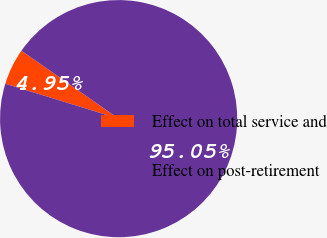Convert chart to OTSL. <chart><loc_0><loc_0><loc_500><loc_500><pie_chart><fcel>Effect on total service and<fcel>Effect on post-retirement<nl><fcel>4.95%<fcel>95.05%<nl></chart> 